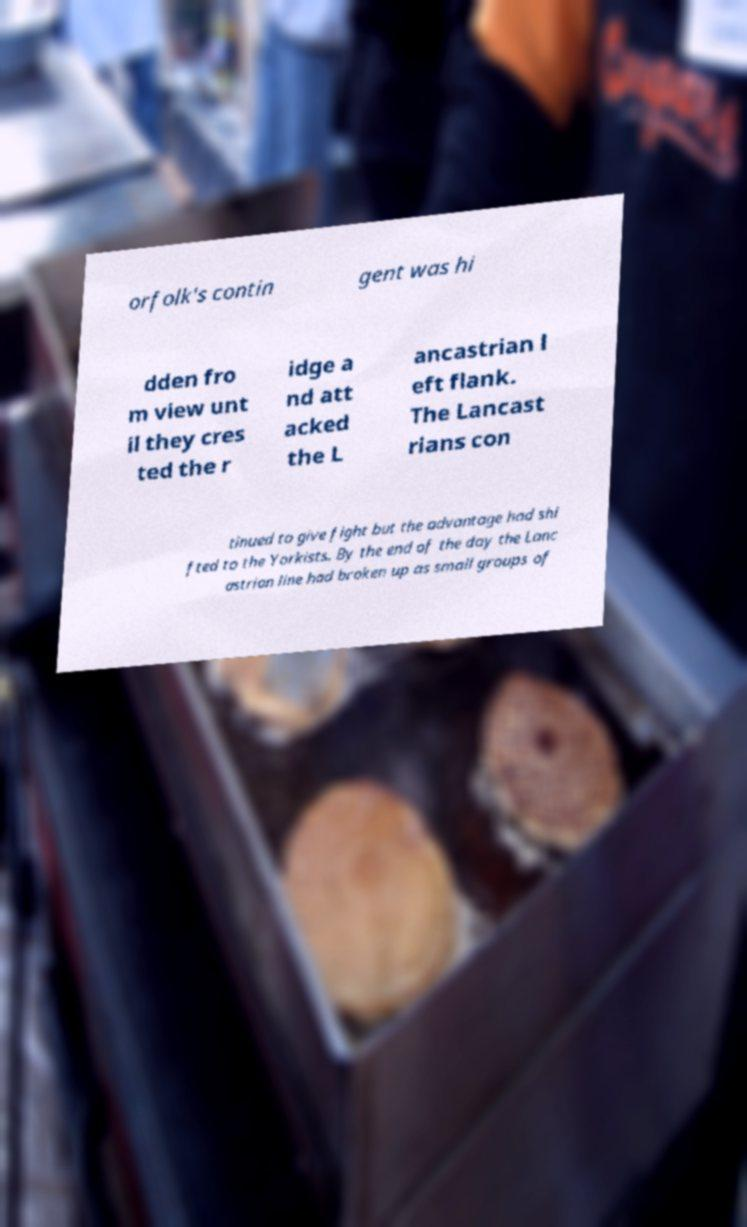Can you read and provide the text displayed in the image?This photo seems to have some interesting text. Can you extract and type it out for me? orfolk's contin gent was hi dden fro m view unt il they cres ted the r idge a nd att acked the L ancastrian l eft flank. The Lancast rians con tinued to give fight but the advantage had shi fted to the Yorkists. By the end of the day the Lanc astrian line had broken up as small groups of 